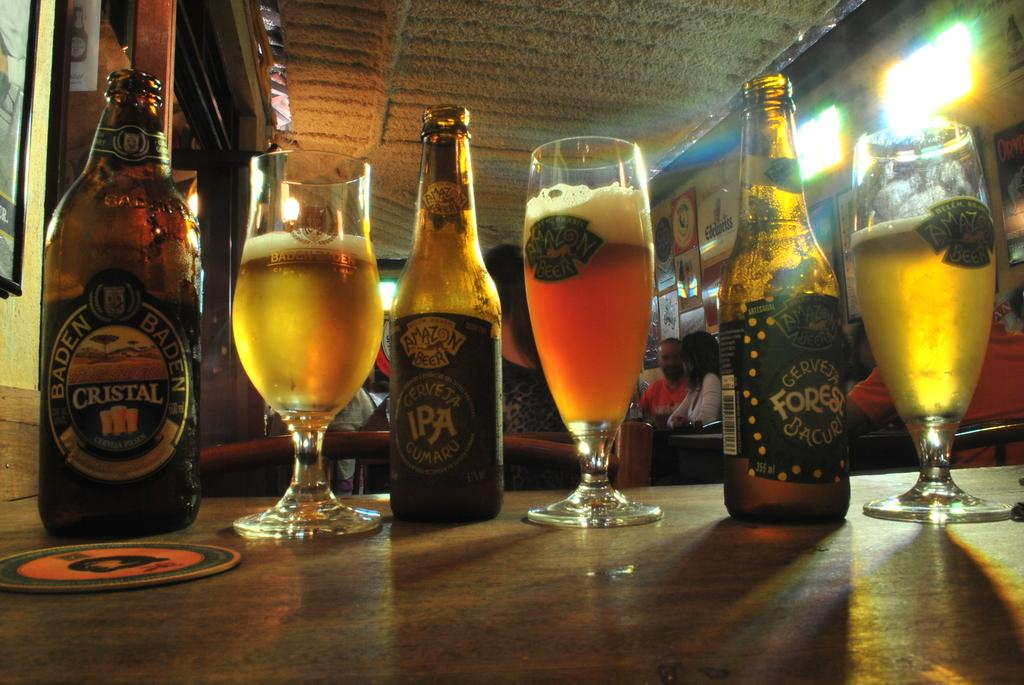<image>
Offer a succinct explanation of the picture presented. Beer bottles and glasses on a counter, including varieties such as Baden Baden Cristal and Amazon Beer. 